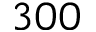<formula> <loc_0><loc_0><loc_500><loc_500>3 0 0</formula> 